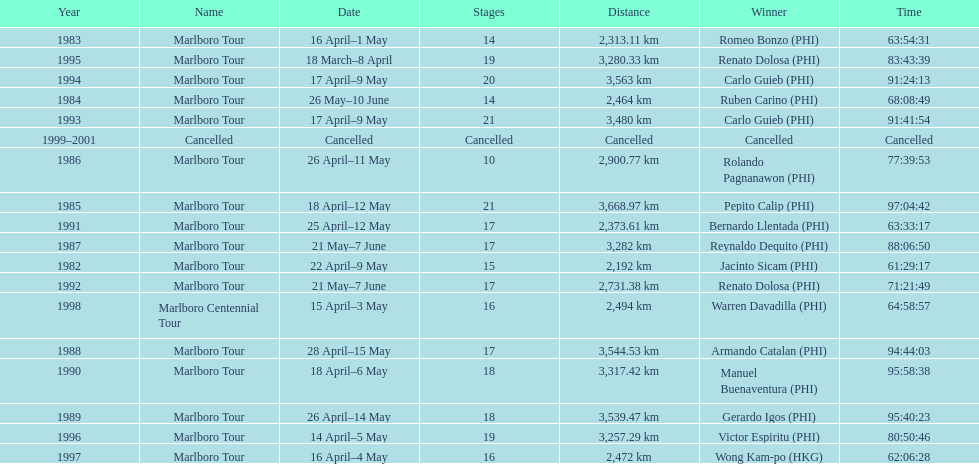What was the total number of winners before the tour was canceled? 17. 